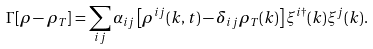Convert formula to latex. <formula><loc_0><loc_0><loc_500><loc_500>\Gamma [ \rho - \rho _ { T } ] = \sum _ { i j } \alpha _ { i j } \left [ \rho ^ { i j } ( k , t ) - \delta _ { i j } \rho _ { T } ( k ) \right ] \xi ^ { i \dagger } ( k ) \xi ^ { j } ( k ) .</formula> 